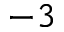<formula> <loc_0><loc_0><loc_500><loc_500>^ { - 3 }</formula> 